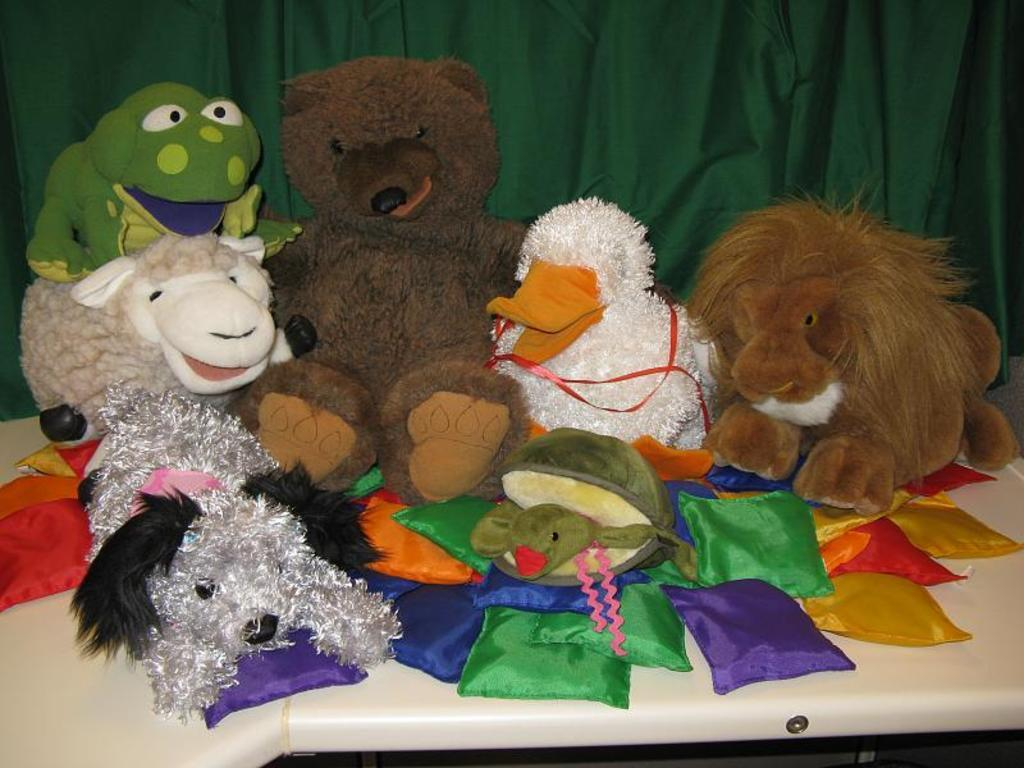What piece of furniture is present in the image? There is a table in the image. What is placed on the table? There is a teddy bear and dolls on the table. What type of items can be seen in the image besides the table and toys? There are clothes visible in the image. What can be seen in the background of the image? There is a curtain in the background of the image. What type of cup is being used to cover the teddy bear in the image? There is no cup present in the image, nor is the teddy bear being covered by any object. 